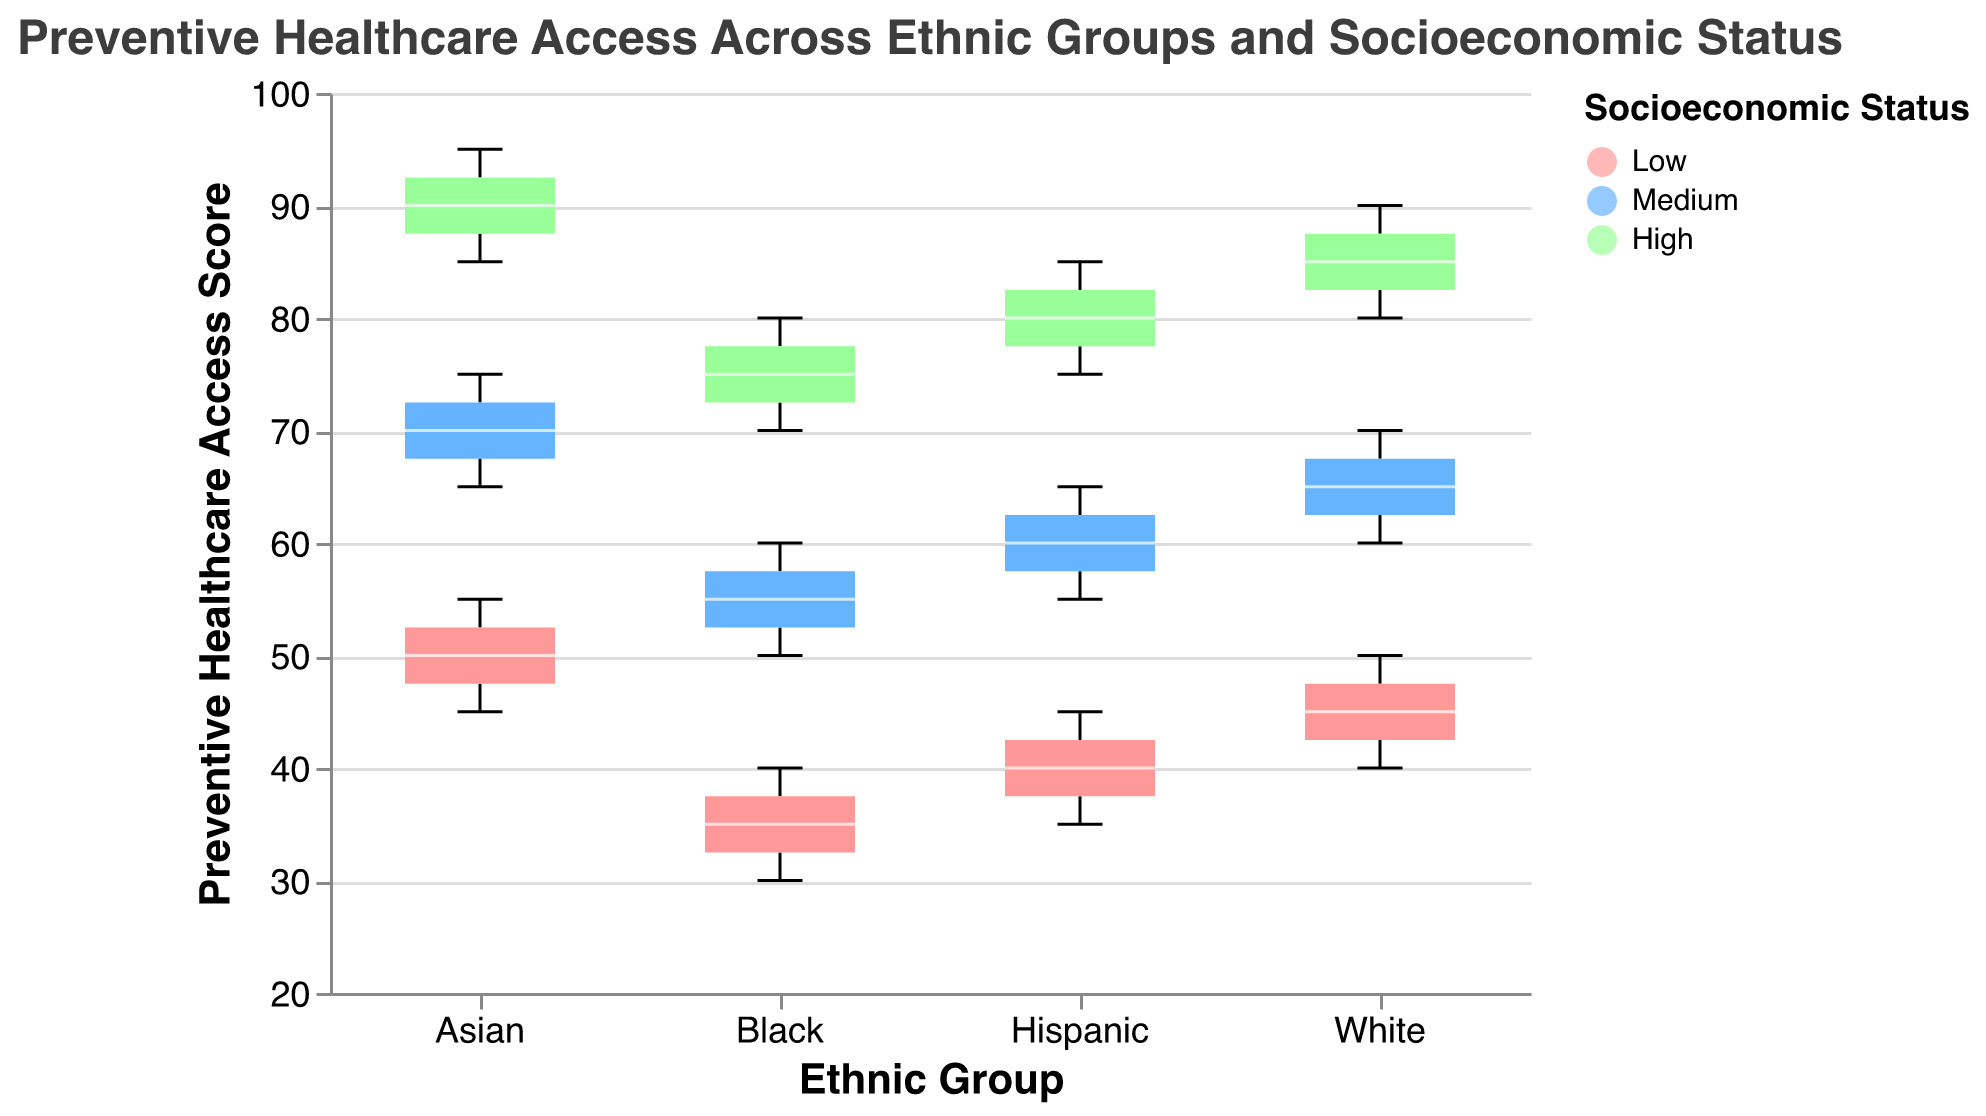What is the title of the figure? Look at the top of the figure where the title is displayed: "Preventive Healthcare Access Across Ethnic Groups and Socioeconomic Status".
Answer: Preventive Healthcare Access Across Ethnic Groups and Socioeconomic Status Which ethnic group has the highest median access score among all socioeconomic statuses? From the box plot, identify the median markers (usually represented by a line inside the box) and compare them across all ethnic groups. The Asian group has the highest median scores in all socioeconomic statuses.
Answer: Asian What is the preventive healthcare access score range for Hispanics with low socioeconomic status? For the Hispanic group with low socioeconomic status, look at the whiskers of the box plot to determine the minimum and maximum values. The range is from 35 to 45.
Answer: 35 to 45 How does the median preventive healthcare access score compare between Black and White individuals with high socioeconomic status? Locate the median lines within the boxes for the Black and White groups with high socioeconomic status. Both groups have median scores of 75 and 85, respectively.
Answer: Black: 75, White: 85 Which socioeconomic status has the widest range of preventive healthcare access scores for the Asian ethnic group? Examine the width between the minimum and maximum whiskers of the Asian group's boxes for each socioeconomic status. The "High" socioeconomic status has the widest range from 85 to 95.
Answer: High What is the acces score range for all ethnic groups with medium socioeconomic status? For each ethnic group with medium socioeconomic status, observe the min and max whiskers to establish the range. The ranges are: White (60-70), Black (50-60), Hispanic (55-65), and Asian (65-75).
Answer: White: 60-70, Black: 50-60, Hispanic: 55-65, Asian: 65-75 Which ethnic group shows the most difference in median score between low and high socioeconomic statuses? Compare the median lines in the box plots of all ethnic groups for low and high statuses. Asians show the most significant difference, from around 50 (Low) to 90 (High).
Answer: Asian Describe how preventive healthcare access varies with socioeconomic status within the Black ethnic group. Analyze the box plots for the Black group across different socioeconomic statuses and indicate how the scores range from low to high. For the Black group, the median scores follow this pattern: Low (30-40), Medium (50-60), and High (70-80).
Answer: It increases as socioeconomic status increases Which ethnic group appears to have the least variability in preventive healthcare access scores across all socioeconomic statuses? Look for the ethnic group with the smallest interquartile ranges and whiskers in their box plots, showing less spread. The White group shows the least variability overall.
Answer: White 